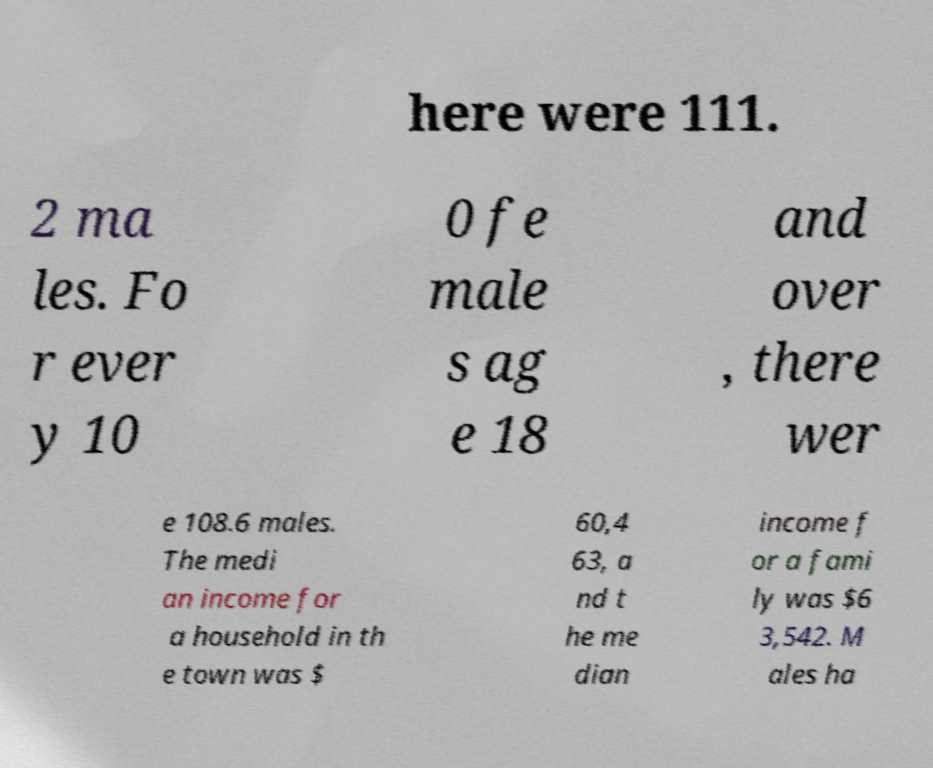Could you extract and type out the text from this image? here were 111. 2 ma les. Fo r ever y 10 0 fe male s ag e 18 and over , there wer e 108.6 males. The medi an income for a household in th e town was $ 60,4 63, a nd t he me dian income f or a fami ly was $6 3,542. M ales ha 